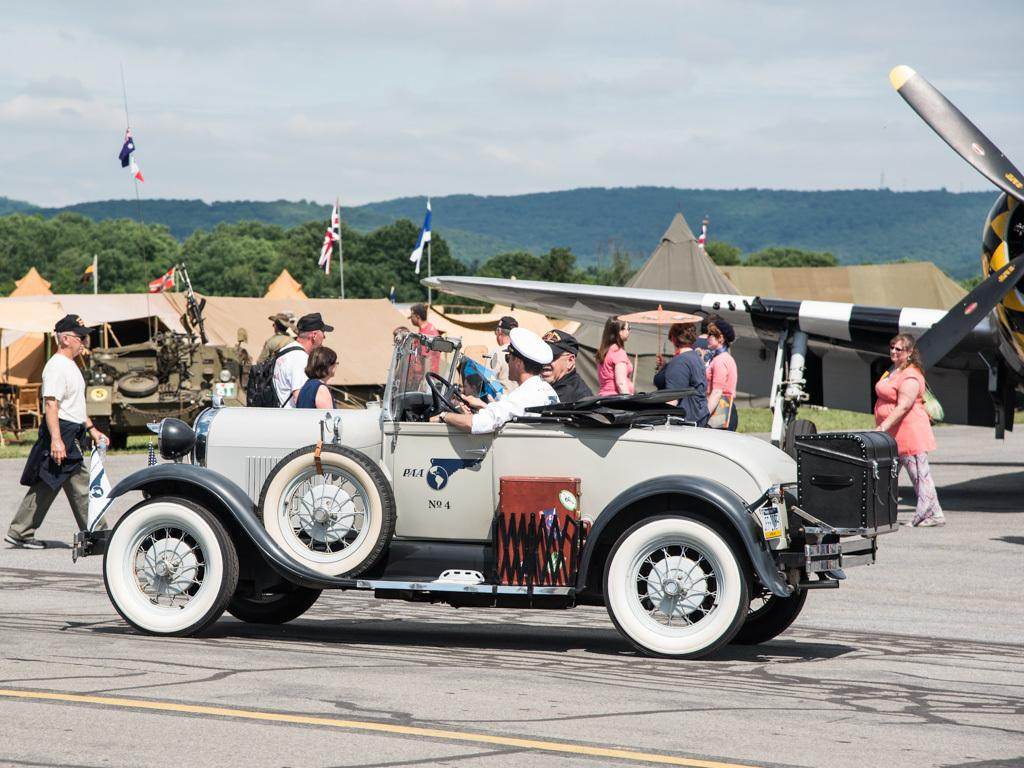What is the main subject of the image? The main subject of the image is a car. Are there any other subjects or objects in the image? Yes, there are people, houses, flags, trees, and the sky visible in the image. What can be seen in the background of the image? The background of the image includes houses, trees, and the sky. Are there any symbols or markers in the image? Yes, there are flags in the image. What type of ink is used to write on the car in the image? There is no writing or ink present on the car in the image. How does the behavior of the trees change throughout the day in the image? The image is a still photograph, so it does not show any changes in the behavior of the trees throughout the day. 